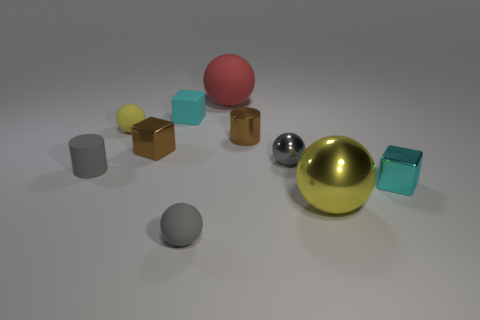What is the shape of the other cyan thing that is the same size as the cyan shiny thing?
Your answer should be compact. Cube. Is there a small gray sphere that is behind the yellow object that is on the right side of the brown cylinder?
Give a very brief answer. Yes. What color is the other small metallic thing that is the same shape as the yellow metallic object?
Your answer should be very brief. Gray. Does the small metal object in front of the rubber cylinder have the same color as the rubber cylinder?
Your answer should be very brief. No. How many objects are cubes to the right of the gray rubber sphere or cylinders?
Provide a succinct answer. 3. There is a cylinder that is behind the gray ball that is on the right side of the large thing that is on the left side of the big metallic thing; what is its material?
Give a very brief answer. Metal. Are there more red rubber things in front of the large red matte ball than tiny yellow objects that are behind the small yellow ball?
Provide a short and direct response. No. What number of cubes are either small cyan metallic things or cyan rubber things?
Provide a succinct answer. 2. There is a shiny ball behind the small shiny block on the right side of the brown shiny cylinder; how many small rubber cylinders are behind it?
Your response must be concise. 0. There is a small thing that is the same color as the big shiny sphere; what material is it?
Give a very brief answer. Rubber. 